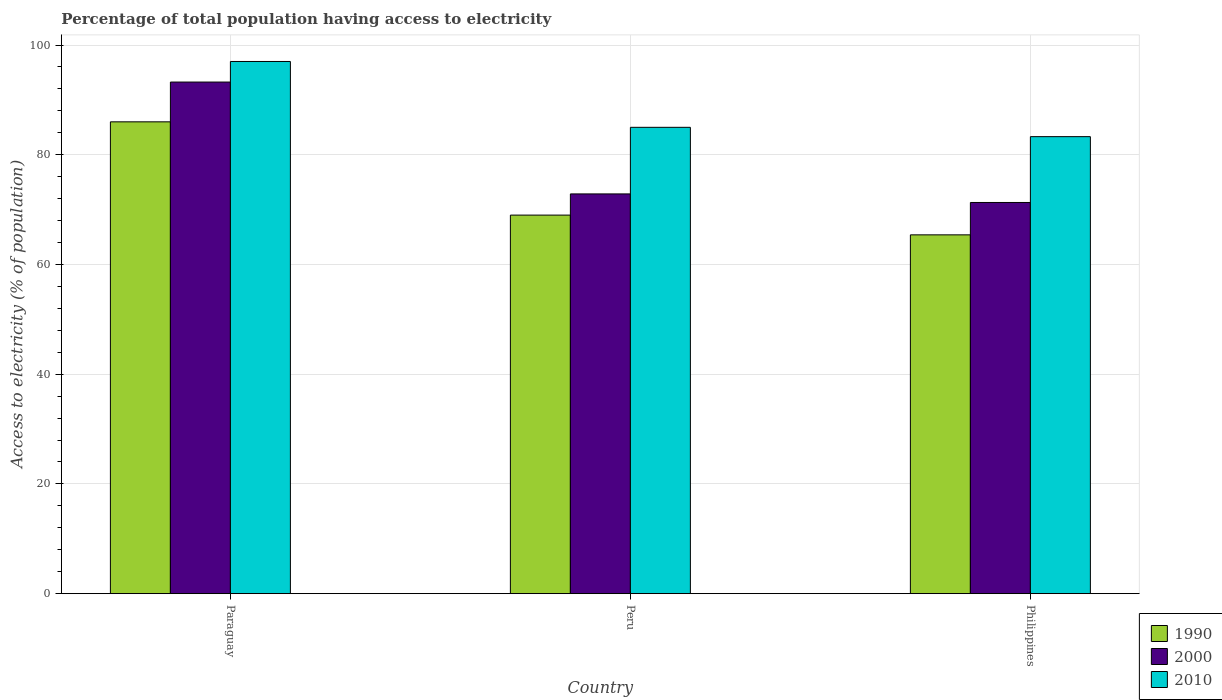How many groups of bars are there?
Your answer should be very brief. 3. How many bars are there on the 2nd tick from the left?
Offer a very short reply. 3. In how many cases, is the number of bars for a given country not equal to the number of legend labels?
Offer a terse response. 0. What is the percentage of population that have access to electricity in 2000 in Philippines?
Your answer should be very brief. 71.3. Across all countries, what is the maximum percentage of population that have access to electricity in 1990?
Provide a short and direct response. 86. Across all countries, what is the minimum percentage of population that have access to electricity in 1990?
Provide a succinct answer. 65.4. In which country was the percentage of population that have access to electricity in 1990 maximum?
Offer a terse response. Paraguay. In which country was the percentage of population that have access to electricity in 2010 minimum?
Offer a terse response. Philippines. What is the total percentage of population that have access to electricity in 2010 in the graph?
Your answer should be compact. 265.3. What is the difference between the percentage of population that have access to electricity in 2010 in Peru and that in Philippines?
Your answer should be compact. 1.7. What is the difference between the percentage of population that have access to electricity in 2010 in Philippines and the percentage of population that have access to electricity in 1990 in Peru?
Provide a short and direct response. 14.3. What is the average percentage of population that have access to electricity in 2000 per country?
Give a very brief answer. 79.14. What is the difference between the percentage of population that have access to electricity of/in 2000 and percentage of population that have access to electricity of/in 2010 in Peru?
Ensure brevity in your answer.  -12.14. In how many countries, is the percentage of population that have access to electricity in 2000 greater than 40 %?
Make the answer very short. 3. What is the ratio of the percentage of population that have access to electricity in 2010 in Paraguay to that in Peru?
Provide a succinct answer. 1.14. What is the difference between the highest and the second highest percentage of population that have access to electricity in 2000?
Offer a terse response. -20.39. What is the difference between the highest and the lowest percentage of population that have access to electricity in 2000?
Provide a succinct answer. 21.95. In how many countries, is the percentage of population that have access to electricity in 1990 greater than the average percentage of population that have access to electricity in 1990 taken over all countries?
Ensure brevity in your answer.  1. Are all the bars in the graph horizontal?
Your answer should be very brief. No. How many countries are there in the graph?
Your response must be concise. 3. What is the difference between two consecutive major ticks on the Y-axis?
Provide a short and direct response. 20. Does the graph contain any zero values?
Ensure brevity in your answer.  No. Where does the legend appear in the graph?
Ensure brevity in your answer.  Bottom right. What is the title of the graph?
Keep it short and to the point. Percentage of total population having access to electricity. Does "1963" appear as one of the legend labels in the graph?
Your response must be concise. No. What is the label or title of the X-axis?
Your answer should be compact. Country. What is the label or title of the Y-axis?
Give a very brief answer. Access to electricity (% of population). What is the Access to electricity (% of population) of 2000 in Paraguay?
Give a very brief answer. 93.25. What is the Access to electricity (% of population) in 2010 in Paraguay?
Provide a short and direct response. 97. What is the Access to electricity (% of population) of 1990 in Peru?
Offer a terse response. 69. What is the Access to electricity (% of population) in 2000 in Peru?
Offer a very short reply. 72.86. What is the Access to electricity (% of population) in 2010 in Peru?
Keep it short and to the point. 85. What is the Access to electricity (% of population) of 1990 in Philippines?
Provide a short and direct response. 65.4. What is the Access to electricity (% of population) in 2000 in Philippines?
Ensure brevity in your answer.  71.3. What is the Access to electricity (% of population) of 2010 in Philippines?
Ensure brevity in your answer.  83.3. Across all countries, what is the maximum Access to electricity (% of population) in 2000?
Make the answer very short. 93.25. Across all countries, what is the maximum Access to electricity (% of population) in 2010?
Keep it short and to the point. 97. Across all countries, what is the minimum Access to electricity (% of population) of 1990?
Keep it short and to the point. 65.4. Across all countries, what is the minimum Access to electricity (% of population) of 2000?
Your response must be concise. 71.3. Across all countries, what is the minimum Access to electricity (% of population) in 2010?
Provide a short and direct response. 83.3. What is the total Access to electricity (% of population) in 1990 in the graph?
Offer a very short reply. 220.4. What is the total Access to electricity (% of population) in 2000 in the graph?
Your answer should be very brief. 237.41. What is the total Access to electricity (% of population) of 2010 in the graph?
Your response must be concise. 265.3. What is the difference between the Access to electricity (% of population) of 2000 in Paraguay and that in Peru?
Your answer should be very brief. 20.39. What is the difference between the Access to electricity (% of population) of 2010 in Paraguay and that in Peru?
Offer a terse response. 12. What is the difference between the Access to electricity (% of population) in 1990 in Paraguay and that in Philippines?
Ensure brevity in your answer.  20.6. What is the difference between the Access to electricity (% of population) in 2000 in Paraguay and that in Philippines?
Ensure brevity in your answer.  21.95. What is the difference between the Access to electricity (% of population) of 2000 in Peru and that in Philippines?
Give a very brief answer. 1.56. What is the difference between the Access to electricity (% of population) in 2010 in Peru and that in Philippines?
Give a very brief answer. 1.7. What is the difference between the Access to electricity (% of population) of 1990 in Paraguay and the Access to electricity (% of population) of 2000 in Peru?
Give a very brief answer. 13.14. What is the difference between the Access to electricity (% of population) in 1990 in Paraguay and the Access to electricity (% of population) in 2010 in Peru?
Make the answer very short. 1. What is the difference between the Access to electricity (% of population) of 2000 in Paraguay and the Access to electricity (% of population) of 2010 in Peru?
Give a very brief answer. 8.25. What is the difference between the Access to electricity (% of population) in 2000 in Paraguay and the Access to electricity (% of population) in 2010 in Philippines?
Provide a succinct answer. 9.95. What is the difference between the Access to electricity (% of population) in 1990 in Peru and the Access to electricity (% of population) in 2000 in Philippines?
Ensure brevity in your answer.  -2.3. What is the difference between the Access to electricity (% of population) of 1990 in Peru and the Access to electricity (% of population) of 2010 in Philippines?
Give a very brief answer. -14.3. What is the difference between the Access to electricity (% of population) of 2000 in Peru and the Access to electricity (% of population) of 2010 in Philippines?
Provide a succinct answer. -10.44. What is the average Access to electricity (% of population) of 1990 per country?
Offer a very short reply. 73.47. What is the average Access to electricity (% of population) in 2000 per country?
Provide a succinct answer. 79.14. What is the average Access to electricity (% of population) of 2010 per country?
Ensure brevity in your answer.  88.43. What is the difference between the Access to electricity (% of population) in 1990 and Access to electricity (% of population) in 2000 in Paraguay?
Offer a very short reply. -7.25. What is the difference between the Access to electricity (% of population) in 2000 and Access to electricity (% of population) in 2010 in Paraguay?
Your answer should be compact. -3.75. What is the difference between the Access to electricity (% of population) of 1990 and Access to electricity (% of population) of 2000 in Peru?
Your response must be concise. -3.86. What is the difference between the Access to electricity (% of population) in 2000 and Access to electricity (% of population) in 2010 in Peru?
Your answer should be compact. -12.14. What is the difference between the Access to electricity (% of population) of 1990 and Access to electricity (% of population) of 2000 in Philippines?
Offer a terse response. -5.9. What is the difference between the Access to electricity (% of population) in 1990 and Access to electricity (% of population) in 2010 in Philippines?
Offer a terse response. -17.9. What is the difference between the Access to electricity (% of population) of 2000 and Access to electricity (% of population) of 2010 in Philippines?
Your answer should be very brief. -12. What is the ratio of the Access to electricity (% of population) in 1990 in Paraguay to that in Peru?
Give a very brief answer. 1.25. What is the ratio of the Access to electricity (% of population) in 2000 in Paraguay to that in Peru?
Offer a very short reply. 1.28. What is the ratio of the Access to electricity (% of population) in 2010 in Paraguay to that in Peru?
Give a very brief answer. 1.14. What is the ratio of the Access to electricity (% of population) of 1990 in Paraguay to that in Philippines?
Offer a very short reply. 1.31. What is the ratio of the Access to electricity (% of population) of 2000 in Paraguay to that in Philippines?
Provide a succinct answer. 1.31. What is the ratio of the Access to electricity (% of population) in 2010 in Paraguay to that in Philippines?
Ensure brevity in your answer.  1.16. What is the ratio of the Access to electricity (% of population) in 1990 in Peru to that in Philippines?
Provide a succinct answer. 1.05. What is the ratio of the Access to electricity (% of population) in 2000 in Peru to that in Philippines?
Give a very brief answer. 1.02. What is the ratio of the Access to electricity (% of population) of 2010 in Peru to that in Philippines?
Provide a succinct answer. 1.02. What is the difference between the highest and the second highest Access to electricity (% of population) of 1990?
Keep it short and to the point. 17. What is the difference between the highest and the second highest Access to electricity (% of population) of 2000?
Your answer should be compact. 20.39. What is the difference between the highest and the second highest Access to electricity (% of population) of 2010?
Your response must be concise. 12. What is the difference between the highest and the lowest Access to electricity (% of population) of 1990?
Give a very brief answer. 20.6. What is the difference between the highest and the lowest Access to electricity (% of population) in 2000?
Ensure brevity in your answer.  21.95. What is the difference between the highest and the lowest Access to electricity (% of population) of 2010?
Make the answer very short. 13.7. 